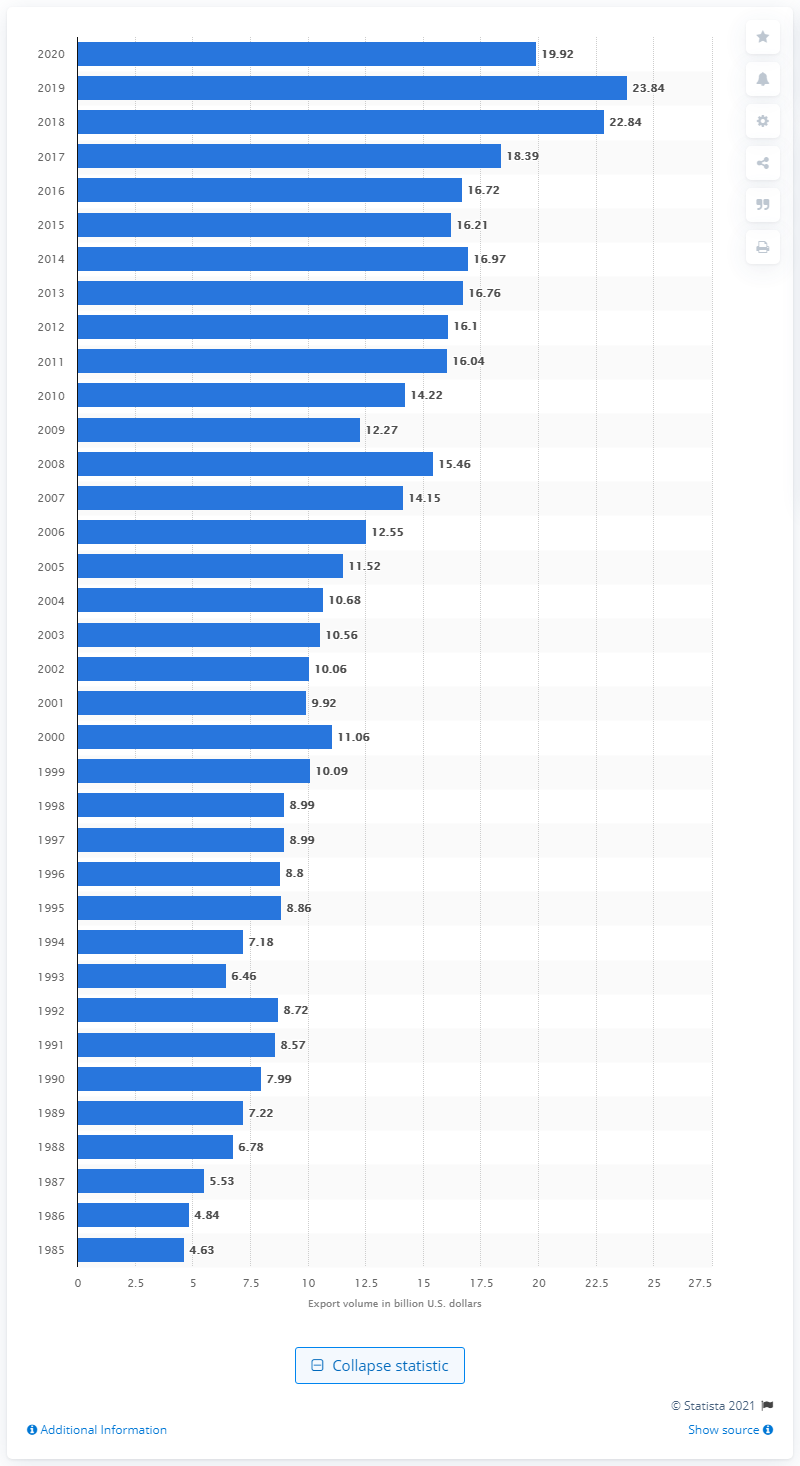Highlight a few significant elements in this photo. In 2020, the United States exported 19.92 billion dollars worth of goods to Italy. 